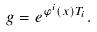Convert formula to latex. <formula><loc_0><loc_0><loc_500><loc_500>g = e ^ { \varphi ^ { i } ( x ) T _ { i } } .</formula> 